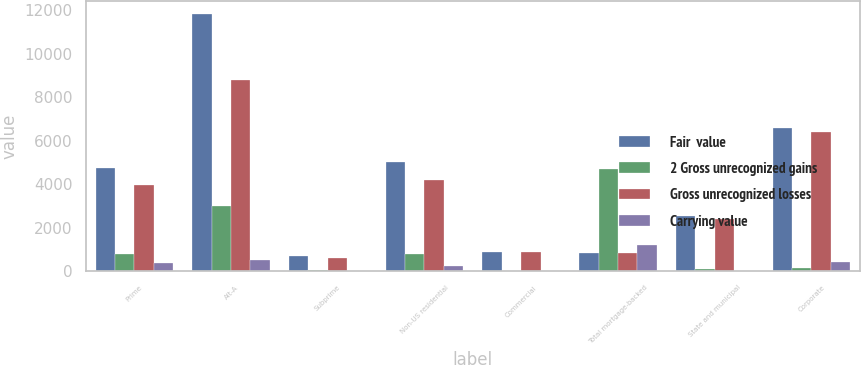Convert chart. <chart><loc_0><loc_0><loc_500><loc_500><stacked_bar_chart><ecel><fcel>Prime<fcel>Alt-A<fcel>Subprime<fcel>Non-US residential<fcel>Commercial<fcel>Total mortgage-backed<fcel>State and municipal<fcel>Corporate<nl><fcel>Fair  value<fcel>4748<fcel>11816<fcel>708<fcel>5010<fcel>908<fcel>840.5<fcel>2523<fcel>6569<nl><fcel>2 Gross unrecognized gains<fcel>794<fcel>3008<fcel>75<fcel>793<fcel>21<fcel>4691<fcel>127<fcel>145<nl><fcel>Gross unrecognized losses<fcel>3954<fcel>8808<fcel>633<fcel>4217<fcel>887<fcel>840.5<fcel>2396<fcel>6424<nl><fcel>Carrying value<fcel>379<fcel>536<fcel>9<fcel>259<fcel>18<fcel>1201<fcel>11<fcel>447<nl></chart> 